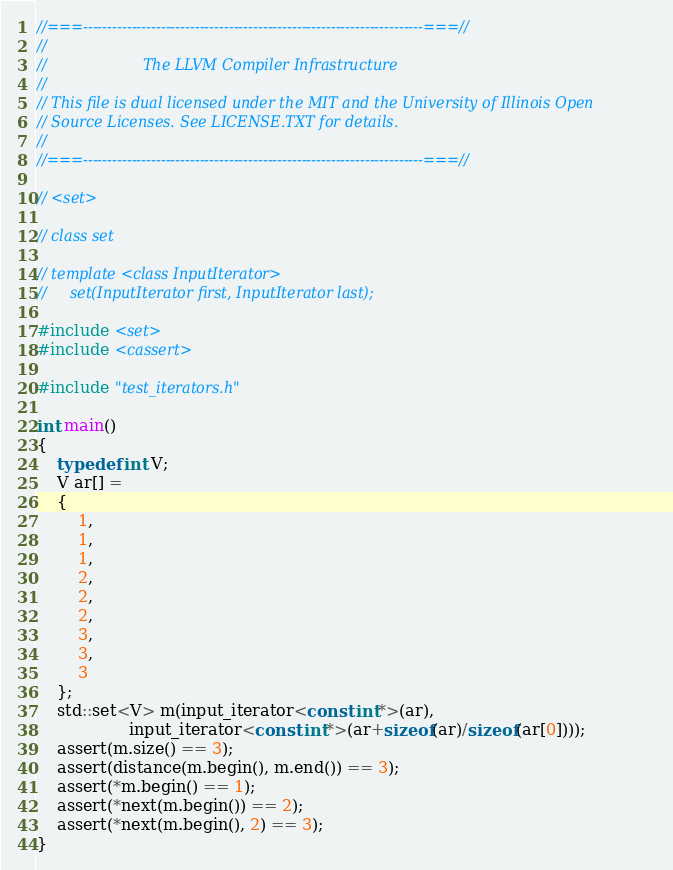Convert code to text. <code><loc_0><loc_0><loc_500><loc_500><_C++_>//===----------------------------------------------------------------------===//
//
//                     The LLVM Compiler Infrastructure
//
// This file is dual licensed under the MIT and the University of Illinois Open
// Source Licenses. See LICENSE.TXT for details.
//
//===----------------------------------------------------------------------===//

// <set>

// class set

// template <class InputIterator>
//     set(InputIterator first, InputIterator last);

#include <set>
#include <cassert>

#include "test_iterators.h"

int main()
{
    typedef int V;
    V ar[] =
    {
        1,
        1,
        1,
        2,
        2,
        2,
        3,
        3,
        3
    };
    std::set<V> m(input_iterator<const int*>(ar),
                  input_iterator<const int*>(ar+sizeof(ar)/sizeof(ar[0])));
    assert(m.size() == 3);
    assert(distance(m.begin(), m.end()) == 3);
    assert(*m.begin() == 1);
    assert(*next(m.begin()) == 2);
    assert(*next(m.begin(), 2) == 3);
}
</code> 